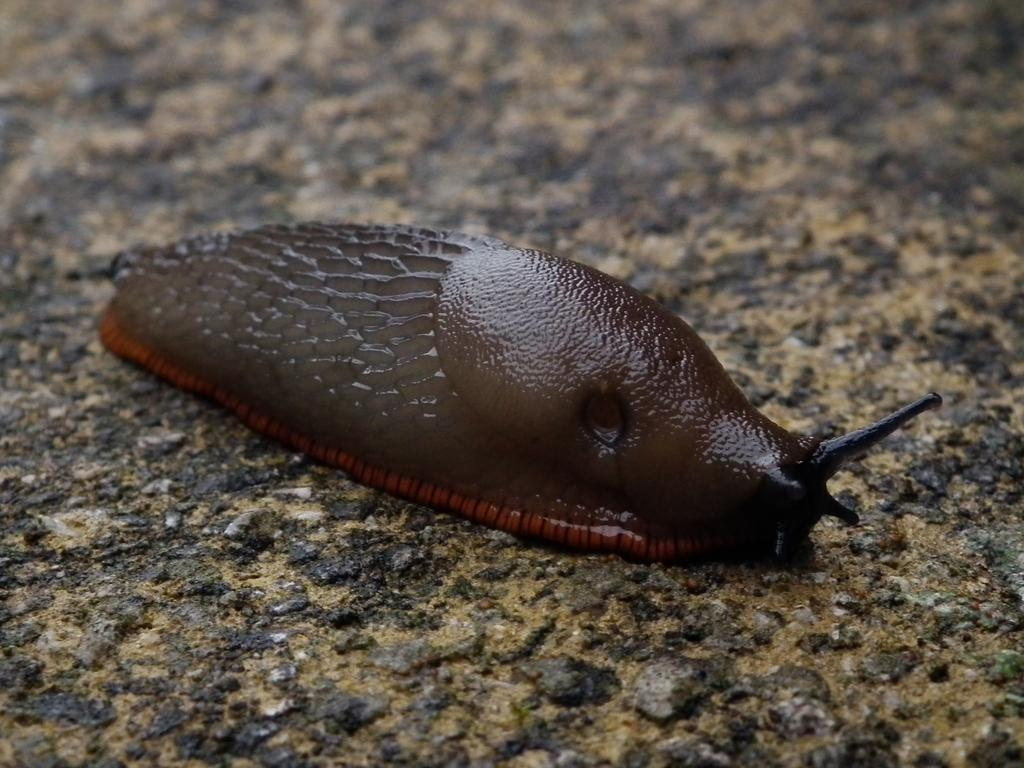What type of animal is in the image? There is a slug in the image. Where is the slug located? The slug is on the ground. Is the slug wearing a ring in the image? There is no ring present in the image, and the slug is not wearing any accessories. 